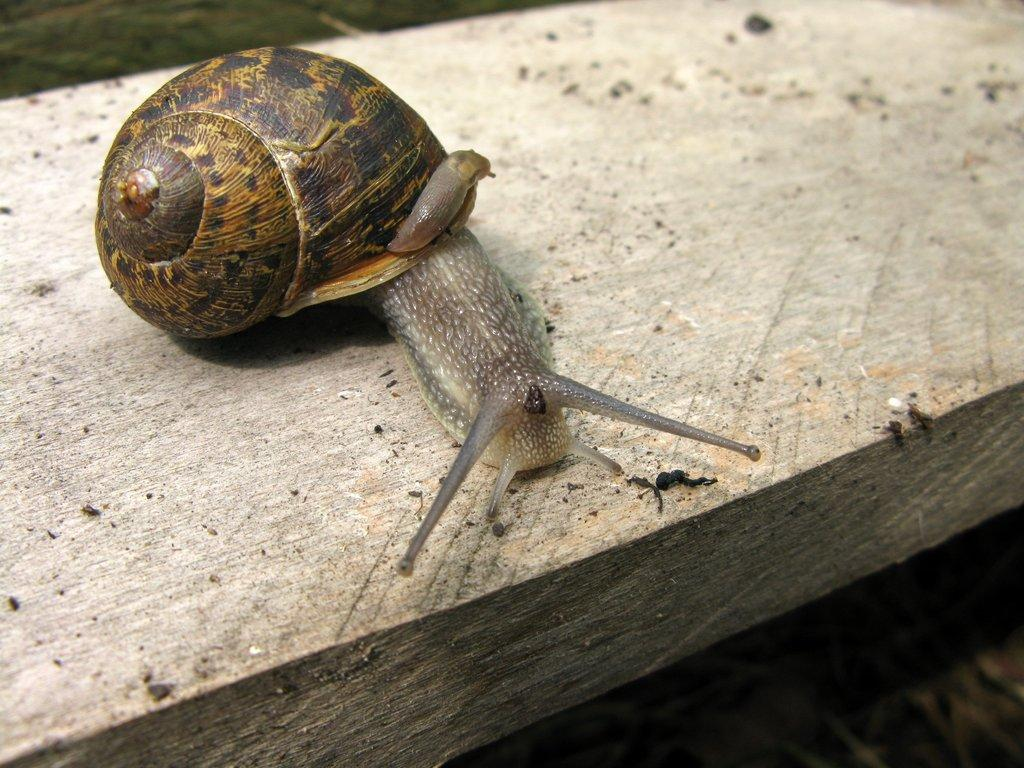What type of animal is present in the image? There is a snail in the image. What is the snail resting on in the image? The snail is on a wooden object. What type of shirt is the snail wearing in the image? There is no shirt present in the image, as snails do not wear clothing. 